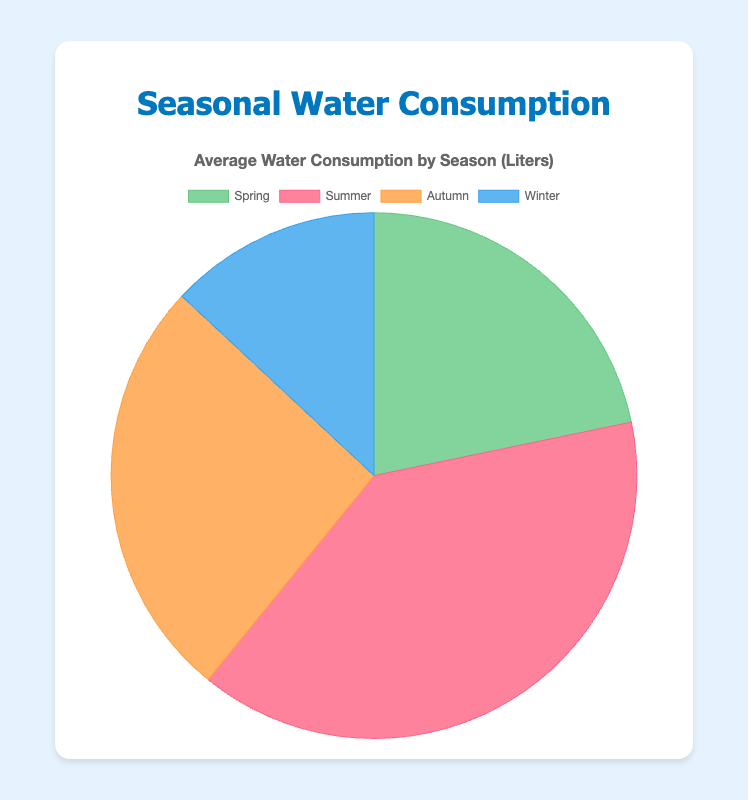Which season has the highest water consumption? By comparing the pie chart slices, it is clear that the 'Summer' slice takes up the largest portion, indicating the highest water consumption.
Answer: Summer Which season has the lowest water consumption? The pie chart shows that 'Winter' has the smallest slice, meaning the lowest water consumption is during winter.
Answer: Winter How much more water is consumed in summer compared to winter? By looking at the data on the pie chart, we see that summer consumption is 45000 liters and winter consumption is 15000 liters. Subtracting these, 45000 - 15000 = 30000 liters.
Answer: 30000 liters What is the total water consumption in liters across all seasons? By adding the average water consumption for all seasons: 25000 (Spring) + 45000 (Summer) + 30000 (Autumn) + 15000 (Winter) = 115000 liters.
Answer: 115000 liters In which season is the water consumption for the northern region highest? From the data provided, the consumption in the northern region is highest in Summer (11000 liters), compared to Spring (7000), Autumn (8000), and Winter (4000).
Answer: Summer How does the autumn water consumption compare to the spring water consumption? The average water consumption in autumn is 30000 liters, and in spring, it is 25000 liters. Autumn has 5000 liters more consumption.
Answer: Autumn has 5000 liters more What percentage of the total water consumption does the summer season account for? Summer's consumption is 45000 liters. The total is 115000 liters. The percentage is calculated as (45000 / 115000) * 100 ≈ 39.13%.
Answer: Approximately 39.13% What is the average water consumption per season in liters? The total consumption across all seasons is 115000 liters. There are 4 seasons. The average is 115000 / 4 = 28750 liters.
Answer: 28750 liters Which color represents the season with the second lowest water consumption? The second lowest water consumption is in Spring (25000 liters), which is represented by green.
Answer: Green What is the difference between water consumption in spring and autumn? Spring consumption is 25000 liters and autumn is 30000 liters. The difference is 30000 - 25000 = 5000 liters.
Answer: 5000 liters 